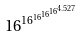Convert formula to latex. <formula><loc_0><loc_0><loc_500><loc_500>1 6 ^ { 1 6 ^ { 1 6 ^ { 1 6 ^ { 1 6 ^ { 4 . 5 2 7 } } } } }</formula> 